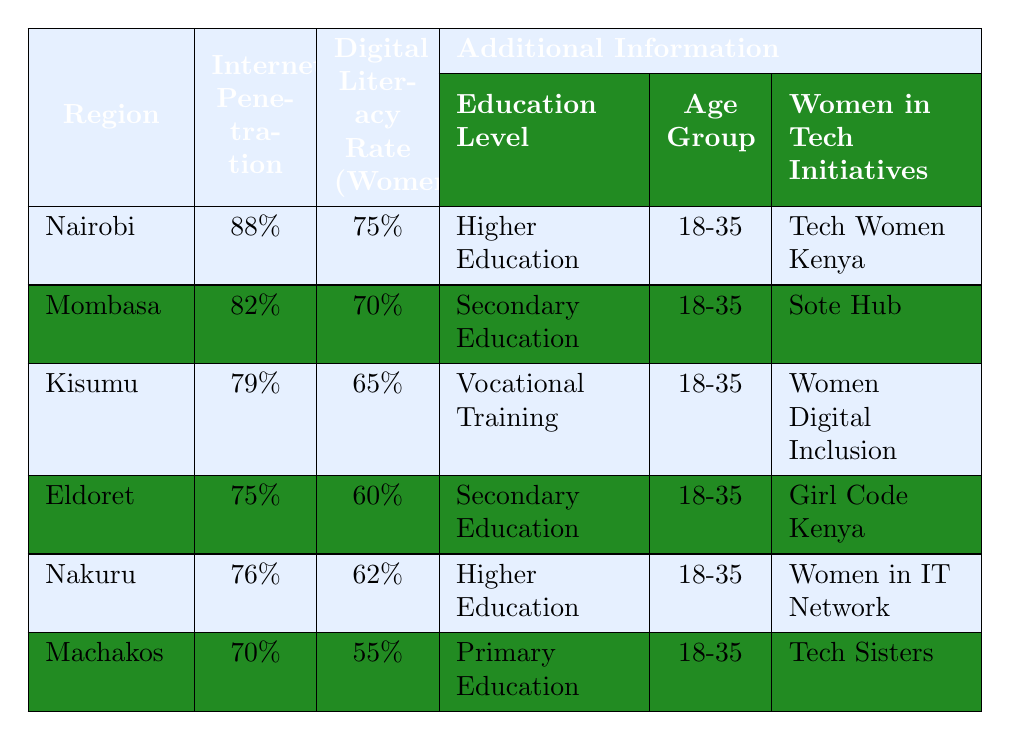What is the Internet penetration rate in Nairobi? According to the table, the Internet penetration rate for Nairobi is listed as 88%.
Answer: 88% Which region has the highest digital literacy rate among women? The table shows that Nairobi has the highest digital literacy rate among women at 75%.
Answer: Nairobi How does the digital literacy rate in Mombasa compare to that in Kisumu? The digital literacy rate in Mombasa is 70%, while in Kisumu it is 65%. Therefore, Mombasa's rate is higher by 5%.
Answer: Mombasa's rate is higher by 5% Calculate the average Internet penetration rate across all regions listed. Adding the Internet penetration rates: 88% + 82% + 79% + 75% + 76% + 70% = 470%. There are 6 regions, so the average is 470% / 6 = 78.33%.
Answer: 78.33% Is Tech Women Kenya the initiative with the lowest digital literacy rate? No, Tech Women Kenya is associated with Nairobi, which has a digital literacy rate of 75%, the highest rate, not the lowest.
Answer: No Which two regions have the same education level for women? The regions Nakuru and Eldoret both have women with secondary education levels.
Answer: Nakuru and Eldoret What is the difference in Internet penetration between the highest and lowest regions? The highest Internet penetration is in Nairobi at 88%, and the lowest is in Machakos at 70%. The difference is 88% - 70% = 18%.
Answer: 18% How many regions have a digital literacy rate for women below 65%? The regions with a digital literacy rate below 65% are Kisumu (65%), Eldoret (60%), Nakuru (62%), and Machakos (55%). Only Machakos has a rate below 65%, thus there is one region.
Answer: 1 If a woman from each region were to join a tech initiative, which region would the woman from Machakos be a part of? The woman from Machakos would be part of the Tech Sisters initiative.
Answer: Tech Sisters Which region has a higher digital literacy rate: Nakuru or Eldoret? Nakuru has a digital literacy rate of 62%, while Eldoret has 60%. Thus, Nakuru has a higher rate by 2%.
Answer: Nakuru has a higher rate 